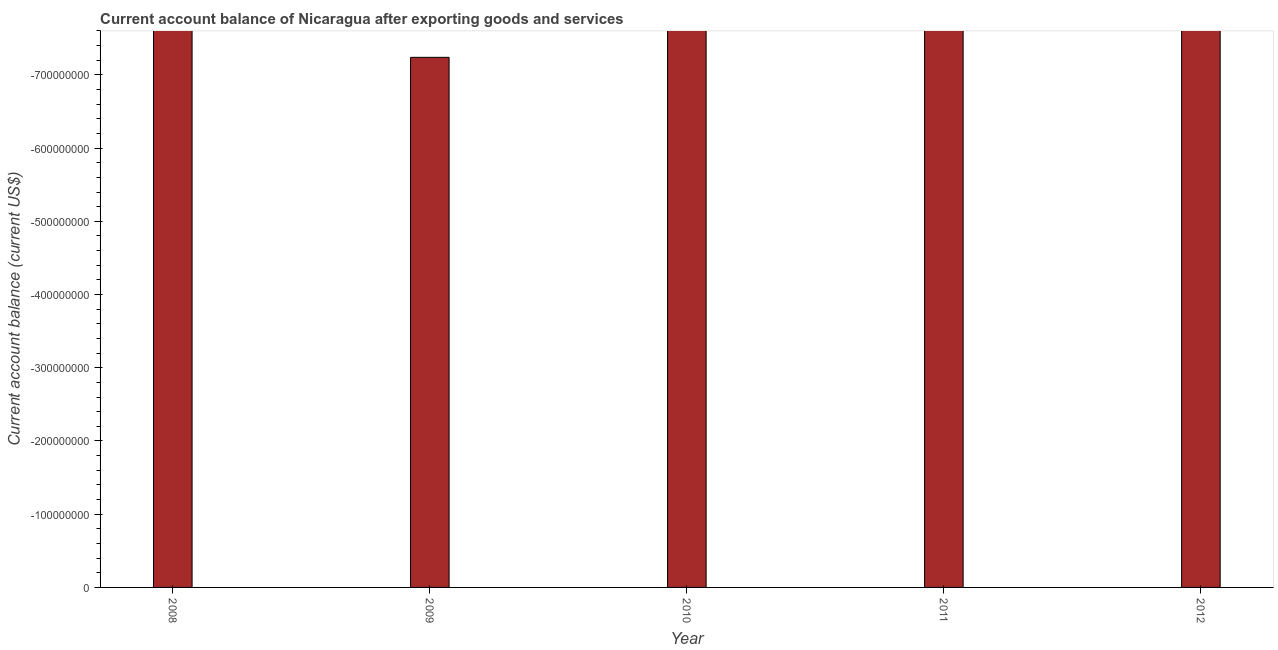Does the graph contain grids?
Ensure brevity in your answer.  No. What is the title of the graph?
Your answer should be very brief. Current account balance of Nicaragua after exporting goods and services. What is the label or title of the Y-axis?
Make the answer very short. Current account balance (current US$). What is the current account balance in 2008?
Offer a very short reply. 0. What is the sum of the current account balance?
Offer a very short reply. 0. What is the average current account balance per year?
Offer a terse response. 0. In how many years, is the current account balance greater than the average current account balance taken over all years?
Your response must be concise. 0. How many bars are there?
Provide a short and direct response. 0. Are all the bars in the graph horizontal?
Give a very brief answer. No. How many years are there in the graph?
Offer a terse response. 5. What is the Current account balance (current US$) in 2008?
Your answer should be very brief. 0. What is the Current account balance (current US$) in 2009?
Your response must be concise. 0. What is the Current account balance (current US$) of 2010?
Provide a succinct answer. 0. What is the Current account balance (current US$) of 2012?
Keep it short and to the point. 0. 